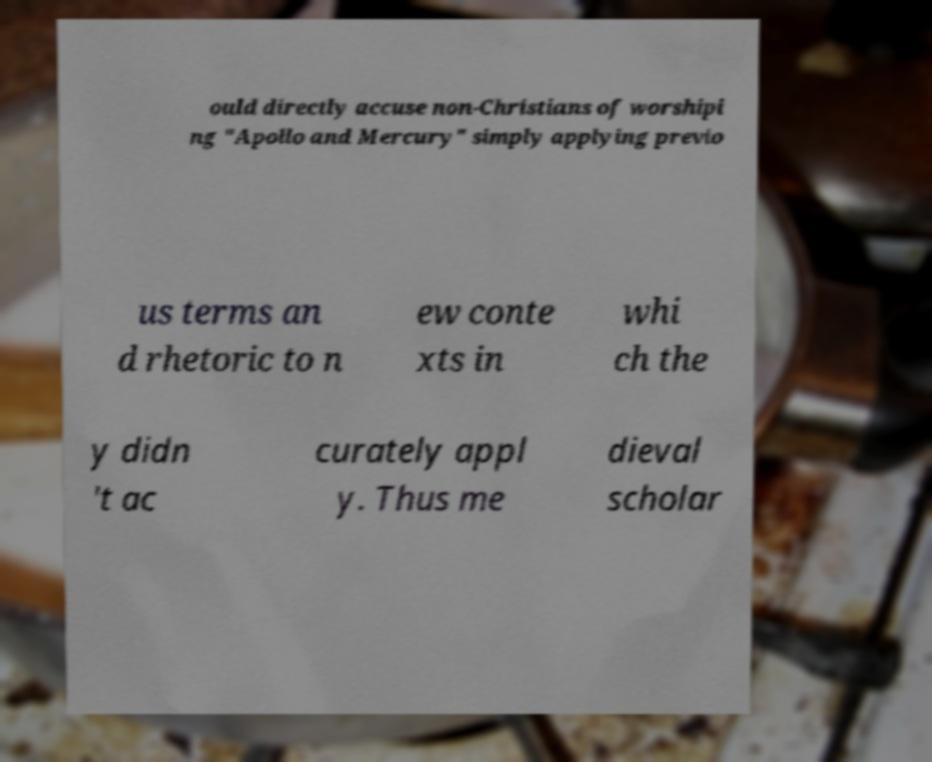Could you assist in decoding the text presented in this image and type it out clearly? ould directly accuse non-Christians of worshipi ng "Apollo and Mercury" simply applying previo us terms an d rhetoric to n ew conte xts in whi ch the y didn 't ac curately appl y. Thus me dieval scholar 